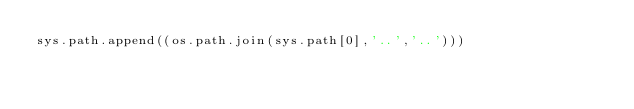<code> <loc_0><loc_0><loc_500><loc_500><_Python_>sys.path.append((os.path.join(sys.path[0],'..','..')))</code> 